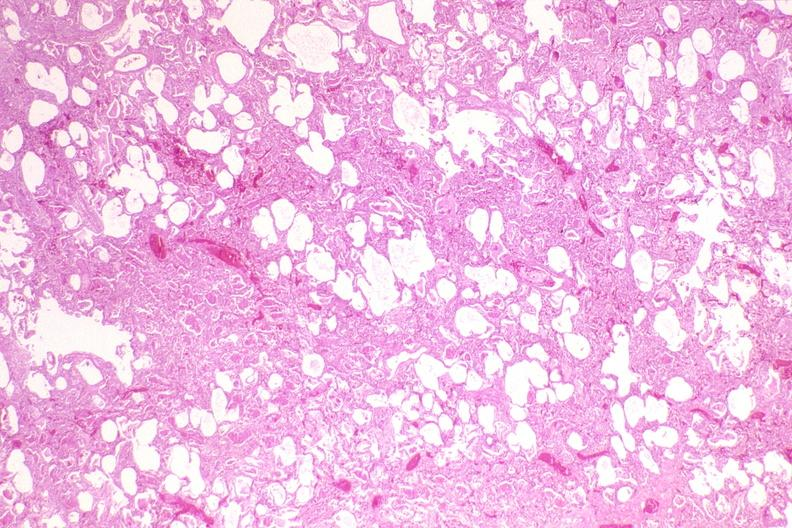what is present?
Answer the question using a single word or phrase. Respiratory 